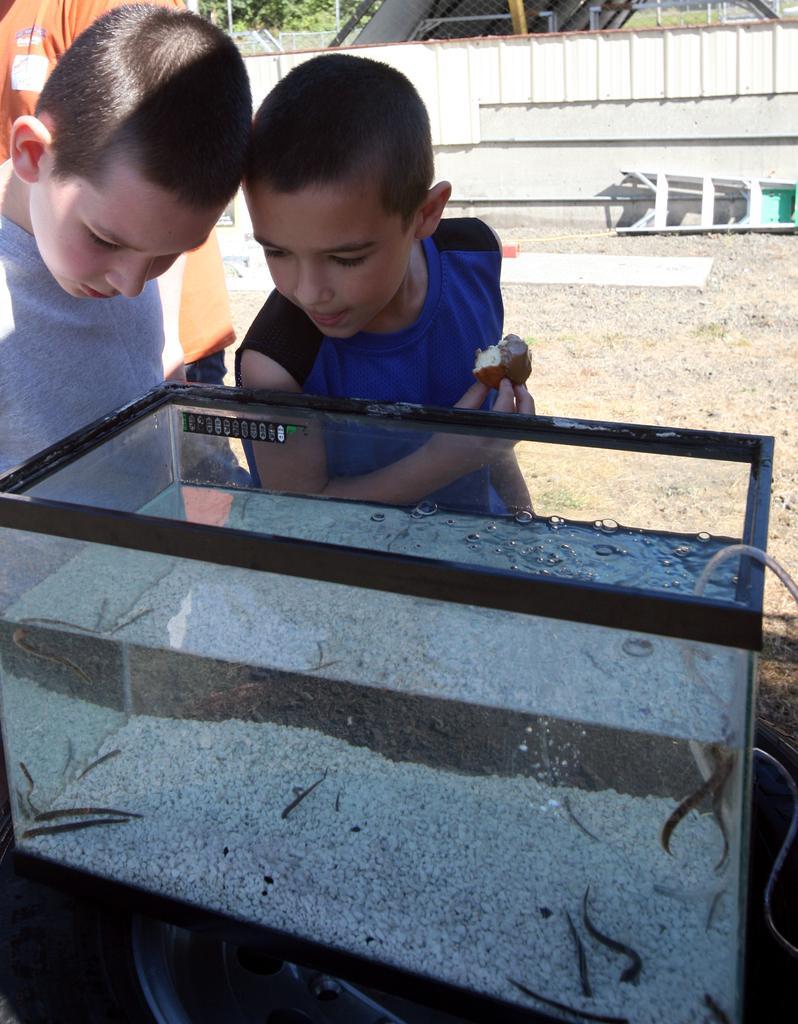Describe this image in one or two sentences. There is an aquarium,some species are kept inside the aquarium and there are two boys beside the aquarium. they are watching the species that are kept inside the aquarium. Behind the boys there is a white fencing around the ground. 